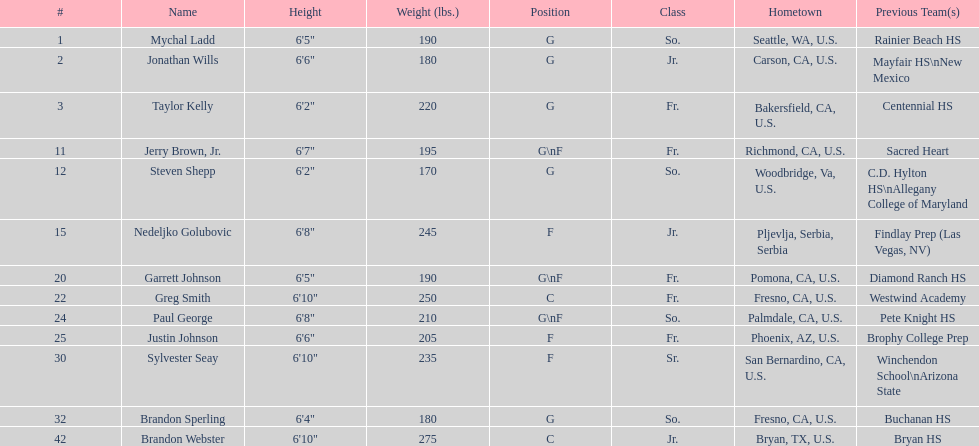Taylor kelly is shorter than 6' 3", which other player is also shorter than 6' 3"? Steven Shepp. 